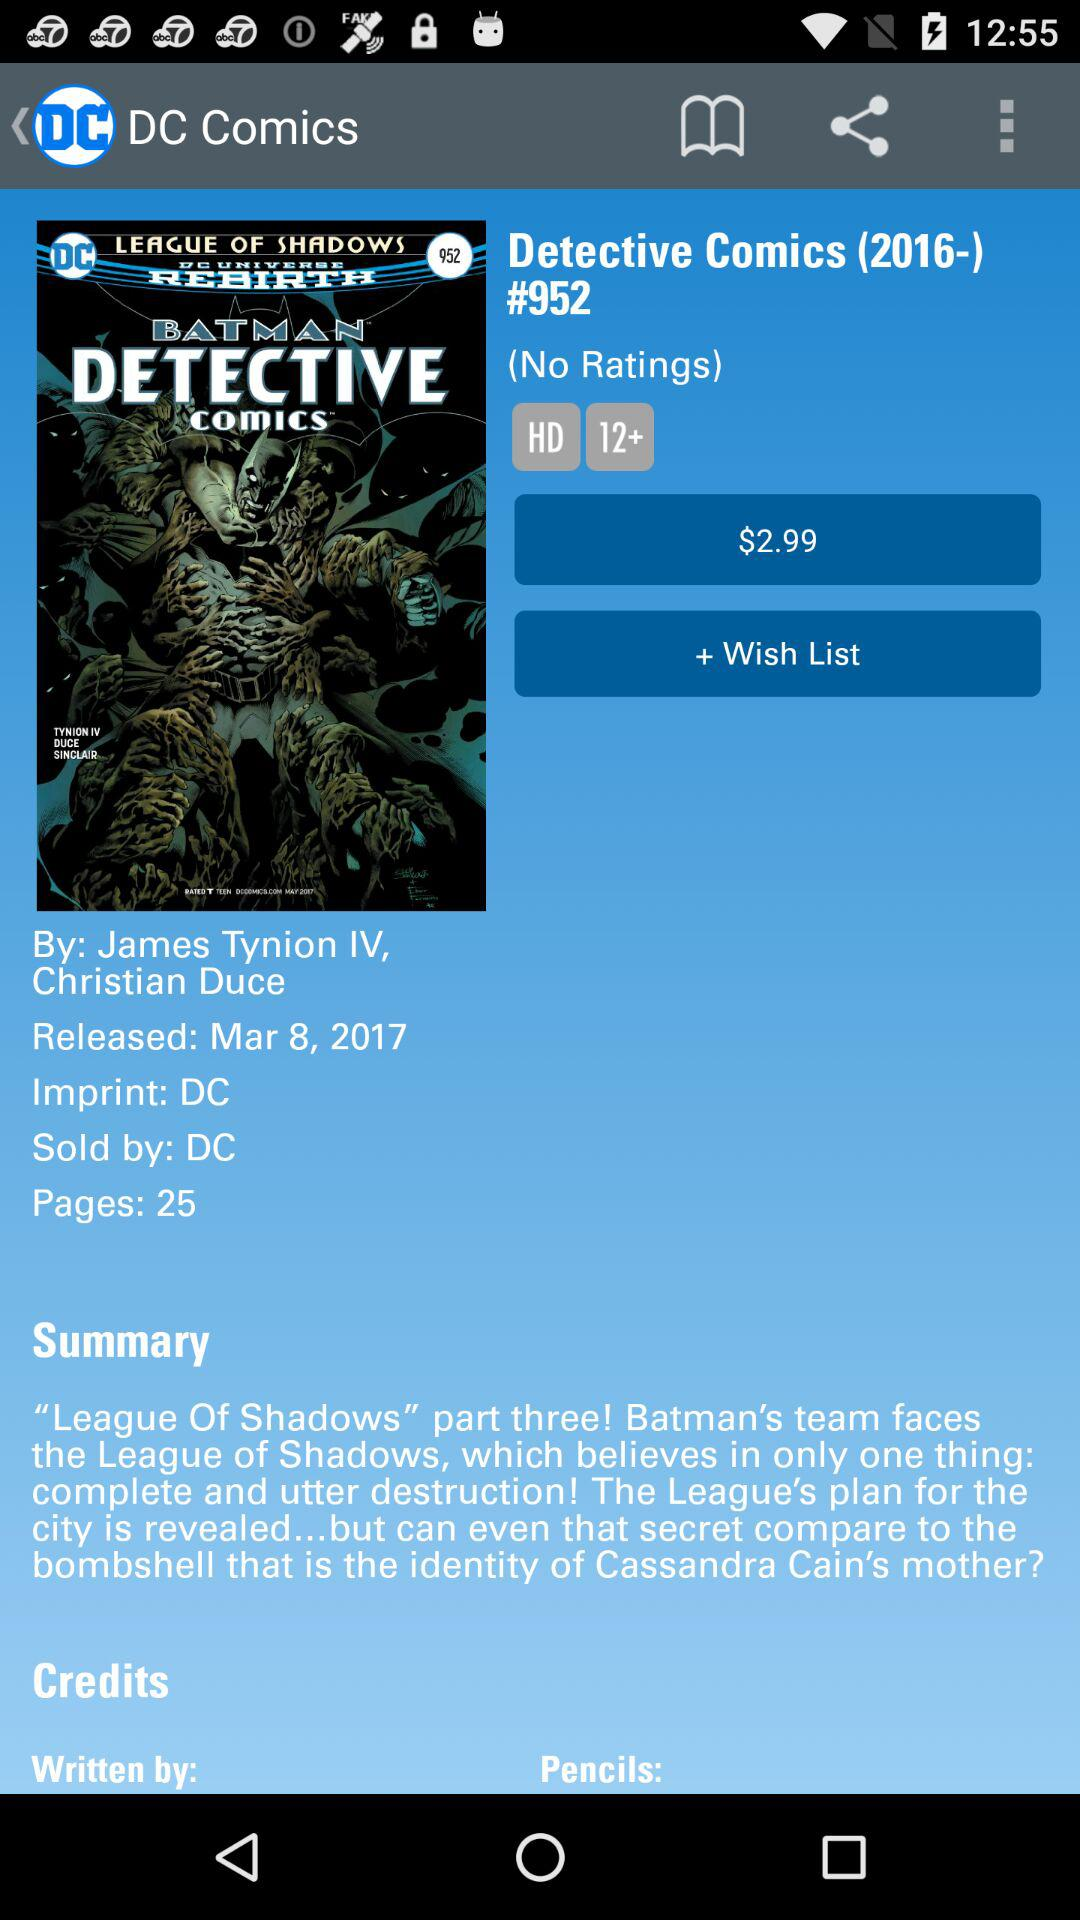What is the price of the comic? The price of the comic is $2.99. 